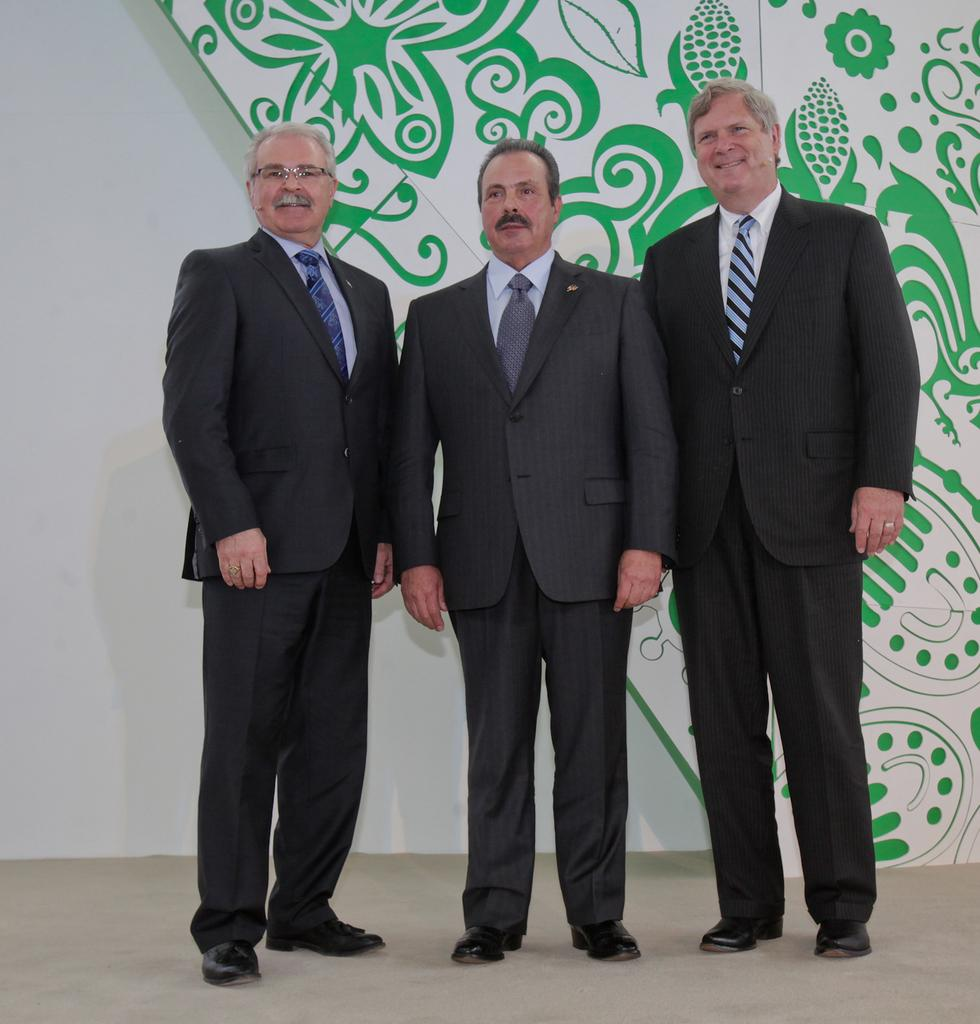How many people are present in the image? There are three people standing in the image. What is the surface on which the people are standing? The people are standing on the floor. What is located behind the people in the image? There is a wall and a design board behind the people. What type of rule is being enforced by the people in the image? There is no indication of any rule being enforced in the image; the people are simply standing. What is causing the people to pay attention in the image? There is no specific reason for the people to pay attention in the image; they are just standing. 